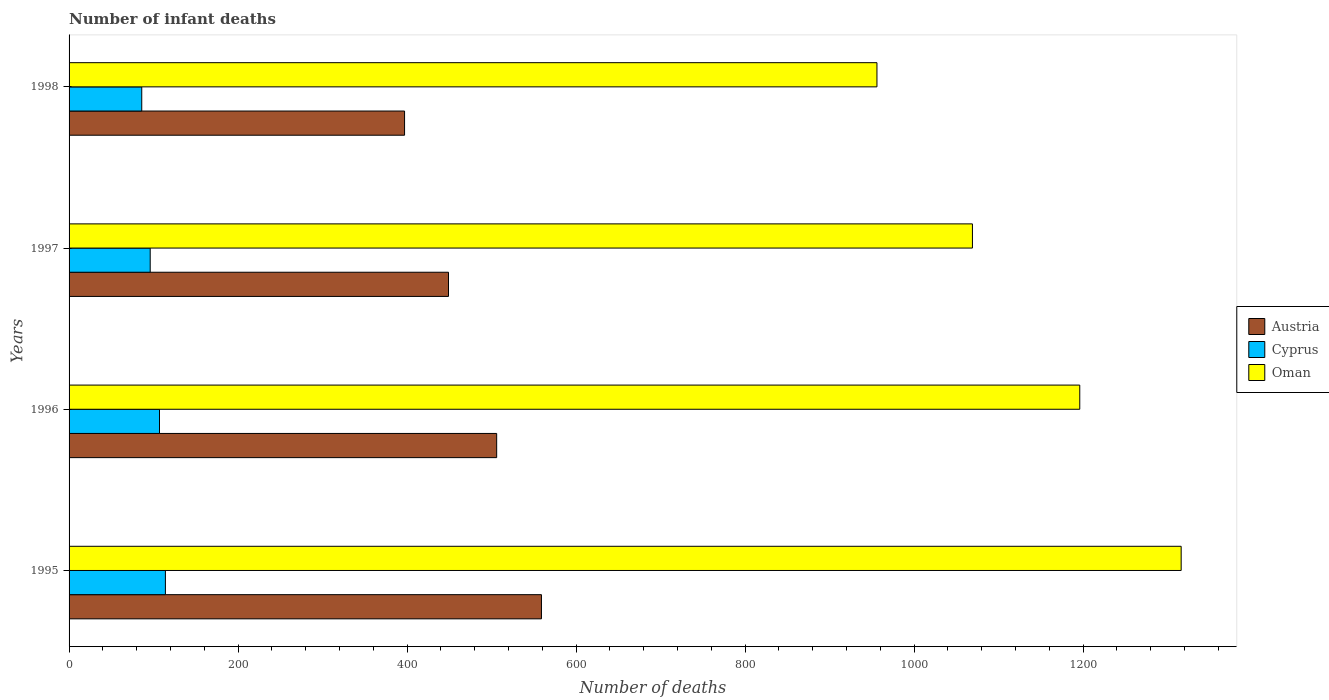Are the number of bars per tick equal to the number of legend labels?
Your response must be concise. Yes. Are the number of bars on each tick of the Y-axis equal?
Make the answer very short. Yes. How many bars are there on the 4th tick from the top?
Your response must be concise. 3. How many bars are there on the 4th tick from the bottom?
Offer a very short reply. 3. In how many cases, is the number of bars for a given year not equal to the number of legend labels?
Your answer should be compact. 0. Across all years, what is the maximum number of infant deaths in Cyprus?
Your answer should be compact. 114. Across all years, what is the minimum number of infant deaths in Austria?
Your response must be concise. 397. In which year was the number of infant deaths in Austria maximum?
Provide a short and direct response. 1995. In which year was the number of infant deaths in Austria minimum?
Offer a terse response. 1998. What is the total number of infant deaths in Cyprus in the graph?
Keep it short and to the point. 403. What is the difference between the number of infant deaths in Austria in 1996 and that in 1997?
Offer a very short reply. 57. What is the difference between the number of infant deaths in Oman in 1996 and the number of infant deaths in Cyprus in 1998?
Your response must be concise. 1110. What is the average number of infant deaths in Cyprus per year?
Ensure brevity in your answer.  100.75. In the year 1996, what is the difference between the number of infant deaths in Austria and number of infant deaths in Oman?
Keep it short and to the point. -690. In how many years, is the number of infant deaths in Austria greater than 240 ?
Offer a very short reply. 4. What is the ratio of the number of infant deaths in Austria in 1996 to that in 1998?
Your answer should be compact. 1.27. What is the difference between the highest and the second highest number of infant deaths in Cyprus?
Provide a short and direct response. 7. What is the difference between the highest and the lowest number of infant deaths in Austria?
Provide a succinct answer. 162. In how many years, is the number of infant deaths in Austria greater than the average number of infant deaths in Austria taken over all years?
Your response must be concise. 2. Is the sum of the number of infant deaths in Austria in 1996 and 1998 greater than the maximum number of infant deaths in Oman across all years?
Your answer should be very brief. No. What does the 1st bar from the top in 1995 represents?
Ensure brevity in your answer.  Oman. What does the 3rd bar from the bottom in 1995 represents?
Offer a terse response. Oman. Is it the case that in every year, the sum of the number of infant deaths in Oman and number of infant deaths in Cyprus is greater than the number of infant deaths in Austria?
Give a very brief answer. Yes. How many bars are there?
Offer a very short reply. 12. Are all the bars in the graph horizontal?
Offer a very short reply. Yes. Are the values on the major ticks of X-axis written in scientific E-notation?
Provide a succinct answer. No. Does the graph contain any zero values?
Provide a succinct answer. No. Does the graph contain grids?
Offer a very short reply. No. What is the title of the graph?
Provide a succinct answer. Number of infant deaths. Does "Middle East & North Africa (developing only)" appear as one of the legend labels in the graph?
Offer a terse response. No. What is the label or title of the X-axis?
Your answer should be compact. Number of deaths. What is the label or title of the Y-axis?
Your answer should be compact. Years. What is the Number of deaths of Austria in 1995?
Ensure brevity in your answer.  559. What is the Number of deaths in Cyprus in 1995?
Your response must be concise. 114. What is the Number of deaths in Oman in 1995?
Ensure brevity in your answer.  1316. What is the Number of deaths in Austria in 1996?
Ensure brevity in your answer.  506. What is the Number of deaths of Cyprus in 1996?
Provide a short and direct response. 107. What is the Number of deaths in Oman in 1996?
Offer a terse response. 1196. What is the Number of deaths in Austria in 1997?
Make the answer very short. 449. What is the Number of deaths of Cyprus in 1997?
Keep it short and to the point. 96. What is the Number of deaths of Oman in 1997?
Keep it short and to the point. 1069. What is the Number of deaths in Austria in 1998?
Offer a very short reply. 397. What is the Number of deaths in Oman in 1998?
Your answer should be compact. 956. Across all years, what is the maximum Number of deaths of Austria?
Offer a terse response. 559. Across all years, what is the maximum Number of deaths of Cyprus?
Provide a succinct answer. 114. Across all years, what is the maximum Number of deaths in Oman?
Offer a very short reply. 1316. Across all years, what is the minimum Number of deaths in Austria?
Provide a succinct answer. 397. Across all years, what is the minimum Number of deaths in Cyprus?
Provide a short and direct response. 86. Across all years, what is the minimum Number of deaths in Oman?
Your response must be concise. 956. What is the total Number of deaths of Austria in the graph?
Provide a short and direct response. 1911. What is the total Number of deaths of Cyprus in the graph?
Keep it short and to the point. 403. What is the total Number of deaths in Oman in the graph?
Offer a very short reply. 4537. What is the difference between the Number of deaths in Oman in 1995 and that in 1996?
Your answer should be very brief. 120. What is the difference between the Number of deaths of Austria in 1995 and that in 1997?
Offer a terse response. 110. What is the difference between the Number of deaths in Oman in 1995 and that in 1997?
Provide a succinct answer. 247. What is the difference between the Number of deaths in Austria in 1995 and that in 1998?
Your response must be concise. 162. What is the difference between the Number of deaths in Oman in 1995 and that in 1998?
Your answer should be very brief. 360. What is the difference between the Number of deaths of Oman in 1996 and that in 1997?
Your answer should be compact. 127. What is the difference between the Number of deaths of Austria in 1996 and that in 1998?
Your answer should be very brief. 109. What is the difference between the Number of deaths in Oman in 1996 and that in 1998?
Your answer should be very brief. 240. What is the difference between the Number of deaths in Oman in 1997 and that in 1998?
Make the answer very short. 113. What is the difference between the Number of deaths in Austria in 1995 and the Number of deaths in Cyprus in 1996?
Give a very brief answer. 452. What is the difference between the Number of deaths of Austria in 1995 and the Number of deaths of Oman in 1996?
Give a very brief answer. -637. What is the difference between the Number of deaths of Cyprus in 1995 and the Number of deaths of Oman in 1996?
Give a very brief answer. -1082. What is the difference between the Number of deaths in Austria in 1995 and the Number of deaths in Cyprus in 1997?
Give a very brief answer. 463. What is the difference between the Number of deaths of Austria in 1995 and the Number of deaths of Oman in 1997?
Give a very brief answer. -510. What is the difference between the Number of deaths in Cyprus in 1995 and the Number of deaths in Oman in 1997?
Offer a very short reply. -955. What is the difference between the Number of deaths in Austria in 1995 and the Number of deaths in Cyprus in 1998?
Ensure brevity in your answer.  473. What is the difference between the Number of deaths in Austria in 1995 and the Number of deaths in Oman in 1998?
Your response must be concise. -397. What is the difference between the Number of deaths of Cyprus in 1995 and the Number of deaths of Oman in 1998?
Your answer should be compact. -842. What is the difference between the Number of deaths in Austria in 1996 and the Number of deaths in Cyprus in 1997?
Provide a short and direct response. 410. What is the difference between the Number of deaths of Austria in 1996 and the Number of deaths of Oman in 1997?
Keep it short and to the point. -563. What is the difference between the Number of deaths of Cyprus in 1996 and the Number of deaths of Oman in 1997?
Your answer should be compact. -962. What is the difference between the Number of deaths of Austria in 1996 and the Number of deaths of Cyprus in 1998?
Offer a very short reply. 420. What is the difference between the Number of deaths in Austria in 1996 and the Number of deaths in Oman in 1998?
Your response must be concise. -450. What is the difference between the Number of deaths in Cyprus in 1996 and the Number of deaths in Oman in 1998?
Your response must be concise. -849. What is the difference between the Number of deaths in Austria in 1997 and the Number of deaths in Cyprus in 1998?
Provide a succinct answer. 363. What is the difference between the Number of deaths in Austria in 1997 and the Number of deaths in Oman in 1998?
Offer a very short reply. -507. What is the difference between the Number of deaths in Cyprus in 1997 and the Number of deaths in Oman in 1998?
Offer a terse response. -860. What is the average Number of deaths of Austria per year?
Your answer should be very brief. 477.75. What is the average Number of deaths of Cyprus per year?
Provide a short and direct response. 100.75. What is the average Number of deaths in Oman per year?
Give a very brief answer. 1134.25. In the year 1995, what is the difference between the Number of deaths of Austria and Number of deaths of Cyprus?
Make the answer very short. 445. In the year 1995, what is the difference between the Number of deaths in Austria and Number of deaths in Oman?
Give a very brief answer. -757. In the year 1995, what is the difference between the Number of deaths of Cyprus and Number of deaths of Oman?
Your response must be concise. -1202. In the year 1996, what is the difference between the Number of deaths in Austria and Number of deaths in Cyprus?
Your answer should be compact. 399. In the year 1996, what is the difference between the Number of deaths of Austria and Number of deaths of Oman?
Keep it short and to the point. -690. In the year 1996, what is the difference between the Number of deaths in Cyprus and Number of deaths in Oman?
Offer a terse response. -1089. In the year 1997, what is the difference between the Number of deaths of Austria and Number of deaths of Cyprus?
Offer a terse response. 353. In the year 1997, what is the difference between the Number of deaths in Austria and Number of deaths in Oman?
Provide a short and direct response. -620. In the year 1997, what is the difference between the Number of deaths of Cyprus and Number of deaths of Oman?
Keep it short and to the point. -973. In the year 1998, what is the difference between the Number of deaths in Austria and Number of deaths in Cyprus?
Provide a succinct answer. 311. In the year 1998, what is the difference between the Number of deaths in Austria and Number of deaths in Oman?
Ensure brevity in your answer.  -559. In the year 1998, what is the difference between the Number of deaths of Cyprus and Number of deaths of Oman?
Provide a short and direct response. -870. What is the ratio of the Number of deaths in Austria in 1995 to that in 1996?
Your answer should be compact. 1.1. What is the ratio of the Number of deaths of Cyprus in 1995 to that in 1996?
Give a very brief answer. 1.07. What is the ratio of the Number of deaths in Oman in 1995 to that in 1996?
Ensure brevity in your answer.  1.1. What is the ratio of the Number of deaths of Austria in 1995 to that in 1997?
Provide a succinct answer. 1.25. What is the ratio of the Number of deaths in Cyprus in 1995 to that in 1997?
Keep it short and to the point. 1.19. What is the ratio of the Number of deaths of Oman in 1995 to that in 1997?
Offer a very short reply. 1.23. What is the ratio of the Number of deaths in Austria in 1995 to that in 1998?
Make the answer very short. 1.41. What is the ratio of the Number of deaths of Cyprus in 1995 to that in 1998?
Your answer should be very brief. 1.33. What is the ratio of the Number of deaths of Oman in 1995 to that in 1998?
Keep it short and to the point. 1.38. What is the ratio of the Number of deaths of Austria in 1996 to that in 1997?
Your answer should be compact. 1.13. What is the ratio of the Number of deaths of Cyprus in 1996 to that in 1997?
Keep it short and to the point. 1.11. What is the ratio of the Number of deaths in Oman in 1996 to that in 1997?
Offer a terse response. 1.12. What is the ratio of the Number of deaths in Austria in 1996 to that in 1998?
Ensure brevity in your answer.  1.27. What is the ratio of the Number of deaths of Cyprus in 1996 to that in 1998?
Offer a terse response. 1.24. What is the ratio of the Number of deaths in Oman in 1996 to that in 1998?
Offer a terse response. 1.25. What is the ratio of the Number of deaths of Austria in 1997 to that in 1998?
Provide a short and direct response. 1.13. What is the ratio of the Number of deaths of Cyprus in 1997 to that in 1998?
Keep it short and to the point. 1.12. What is the ratio of the Number of deaths of Oman in 1997 to that in 1998?
Your answer should be compact. 1.12. What is the difference between the highest and the second highest Number of deaths of Austria?
Give a very brief answer. 53. What is the difference between the highest and the second highest Number of deaths in Cyprus?
Give a very brief answer. 7. What is the difference between the highest and the second highest Number of deaths in Oman?
Ensure brevity in your answer.  120. What is the difference between the highest and the lowest Number of deaths in Austria?
Your answer should be very brief. 162. What is the difference between the highest and the lowest Number of deaths in Oman?
Offer a very short reply. 360. 